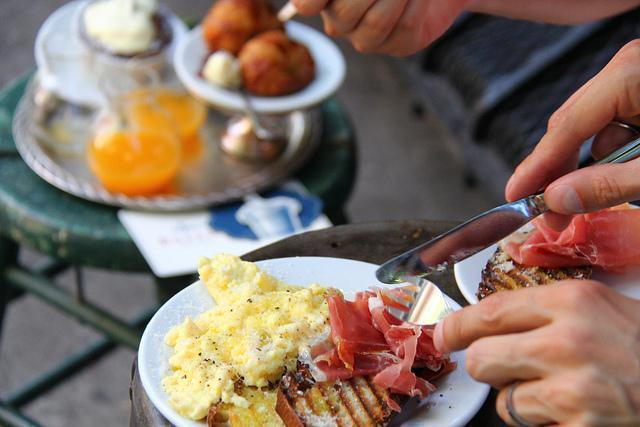What kind of fish is consumed on the side of the breakfast?
Indicate the correct response and explain using: 'Answer: answer
Rationale: rationale.'
Options: Bacon, beef, sausage, salmon. Answer: salmon.
Rationale: The fish is salmon. 